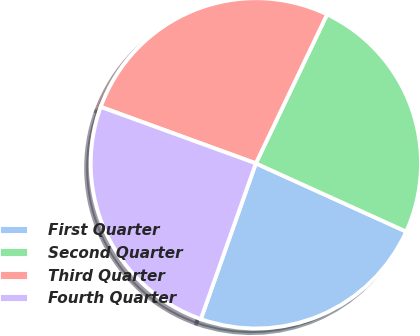Convert chart to OTSL. <chart><loc_0><loc_0><loc_500><loc_500><pie_chart><fcel>First Quarter<fcel>Second Quarter<fcel>Third Quarter<fcel>Fourth Quarter<nl><fcel>23.62%<fcel>24.68%<fcel>26.54%<fcel>25.15%<nl></chart> 